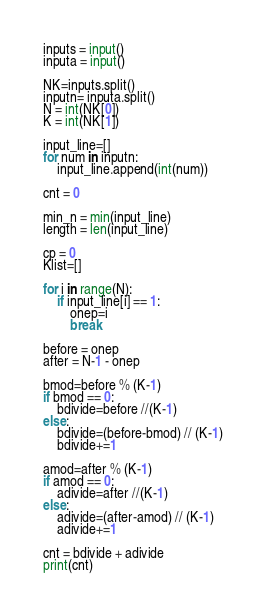Convert code to text. <code><loc_0><loc_0><loc_500><loc_500><_Python_>inputs = input()
inputa = input()

NK=inputs.split()
inputn= inputa.split()
N = int(NK[0])
K = int(NK[1])

input_line=[]
for num in inputn:
    input_line.append(int(num))

cnt = 0

min_n = min(input_line)
length = len(input_line)

cp = 0
Klist=[]

for i in range(N):
    if input_line[i] == 1:
        onep=i
        break
        
before = onep
after = N-1 - onep

bmod=before % (K-1)
if bmod == 0:
    bdivide=before //(K-1)
else:
    bdivide=(before-bmod) // (K-1)
    bdivide+=1

amod=after % (K-1)
if amod == 0:
    adivide=after //(K-1)
else:
    adivide=(after-amod) // (K-1)
    adivide+=1

cnt = bdivide + adivide 
print(cnt)
</code> 